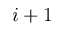<formula> <loc_0><loc_0><loc_500><loc_500>i + 1</formula> 